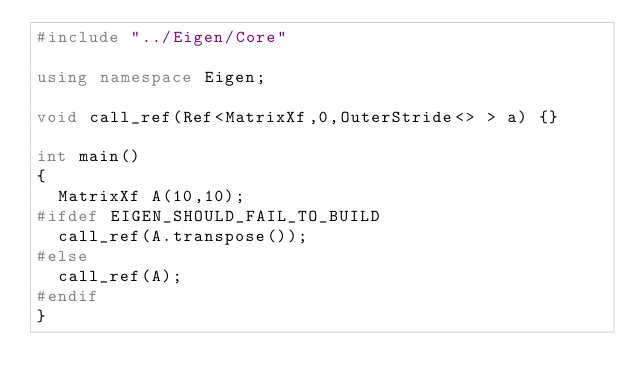<code> <loc_0><loc_0><loc_500><loc_500><_C++_>#include "../Eigen/Core"

using namespace Eigen;

void call_ref(Ref<MatrixXf,0,OuterStride<> > a) {}

int main()
{
  MatrixXf A(10,10);
#ifdef EIGEN_SHOULD_FAIL_TO_BUILD
  call_ref(A.transpose());
#else
  call_ref(A);
#endif
}
</code> 